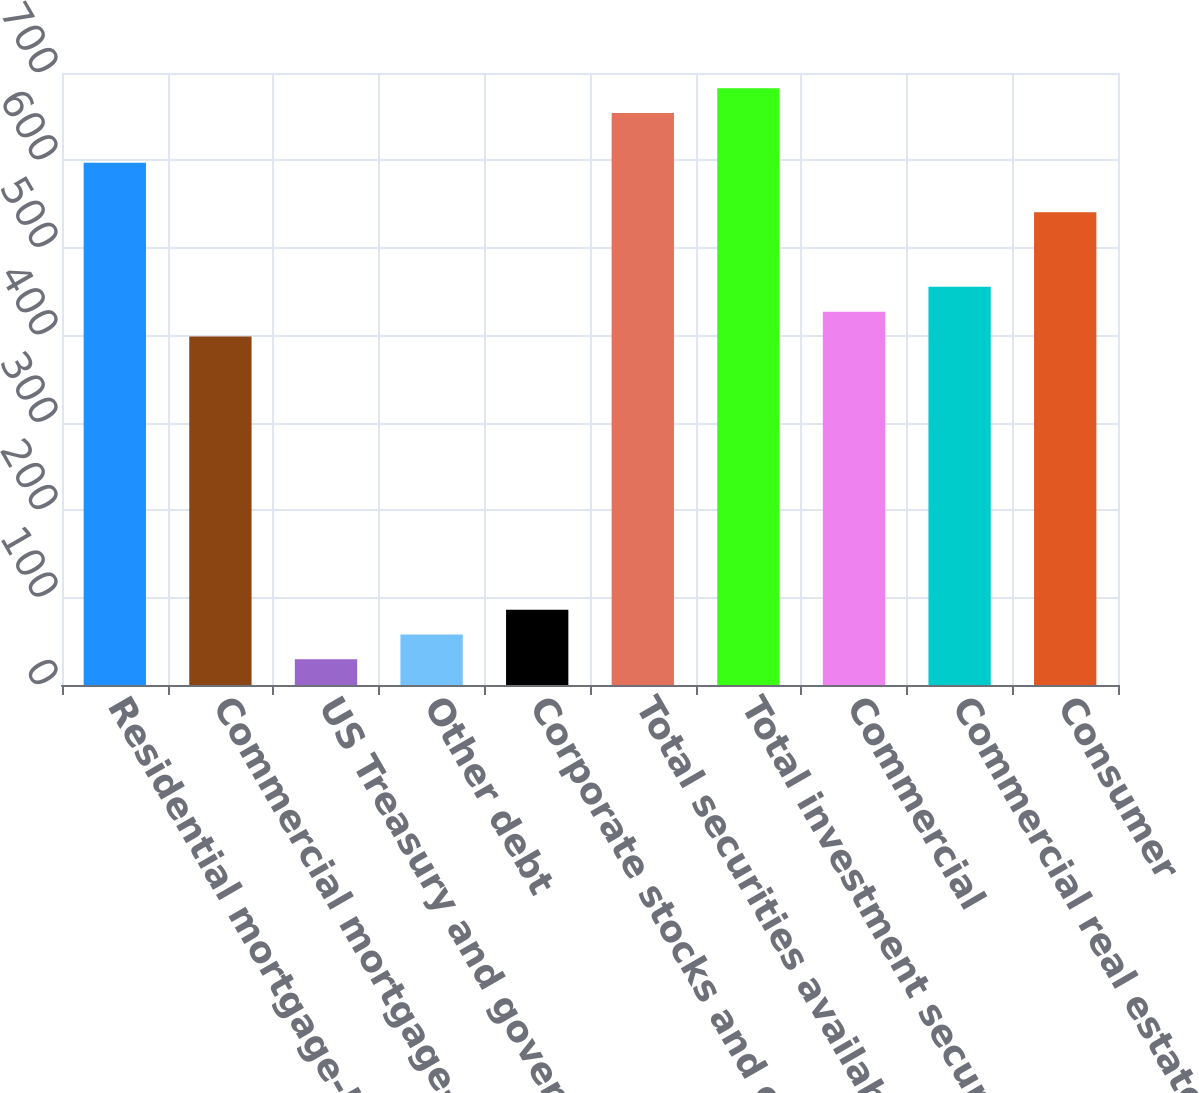Convert chart to OTSL. <chart><loc_0><loc_0><loc_500><loc_500><bar_chart><fcel>Residential mortgage-backed<fcel>Commercial mortgage-backed<fcel>US Treasury and government<fcel>Other debt<fcel>Corporate stocks and other<fcel>Total securities available for<fcel>Total investment securities<fcel>Commercial<fcel>Commercial real estate<fcel>Consumer<nl><fcel>597.4<fcel>398.6<fcel>29.4<fcel>57.8<fcel>86.2<fcel>654.2<fcel>682.6<fcel>427<fcel>455.4<fcel>540.6<nl></chart> 